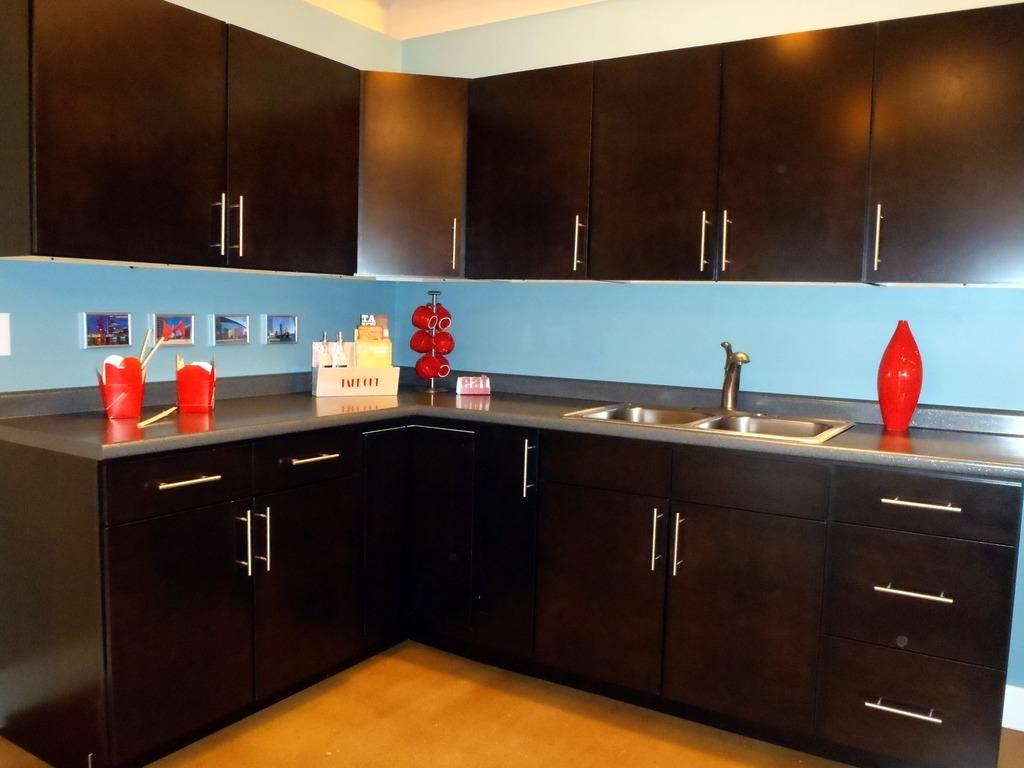What type of room is shown in the image? The image depicts a kitchen. What can be found on the countertop in the kitchen? The countertop contains cups. What is typically used for washing dishes in a kitchen? There is a sink in the kitchen. Where are items like plates and utensils usually stored in a kitchen? There are cupboards in the kitchen. What type of advertisement can be seen on the wall in the kitchen? There is no advertisement present on the wall in the kitchen. What color are the eyes of the person cooking in the kitchen? There is no person cooking in the kitchen, so their eye color cannot be determined. 